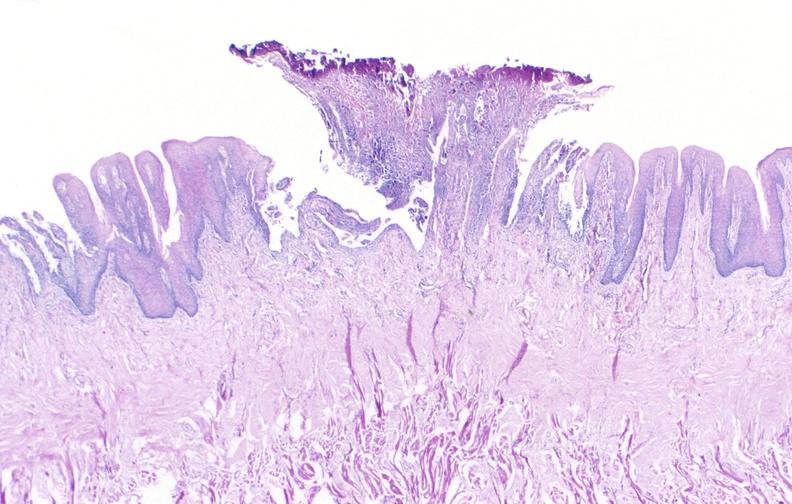s close-up of lesion present?
Answer the question using a single word or phrase. No 